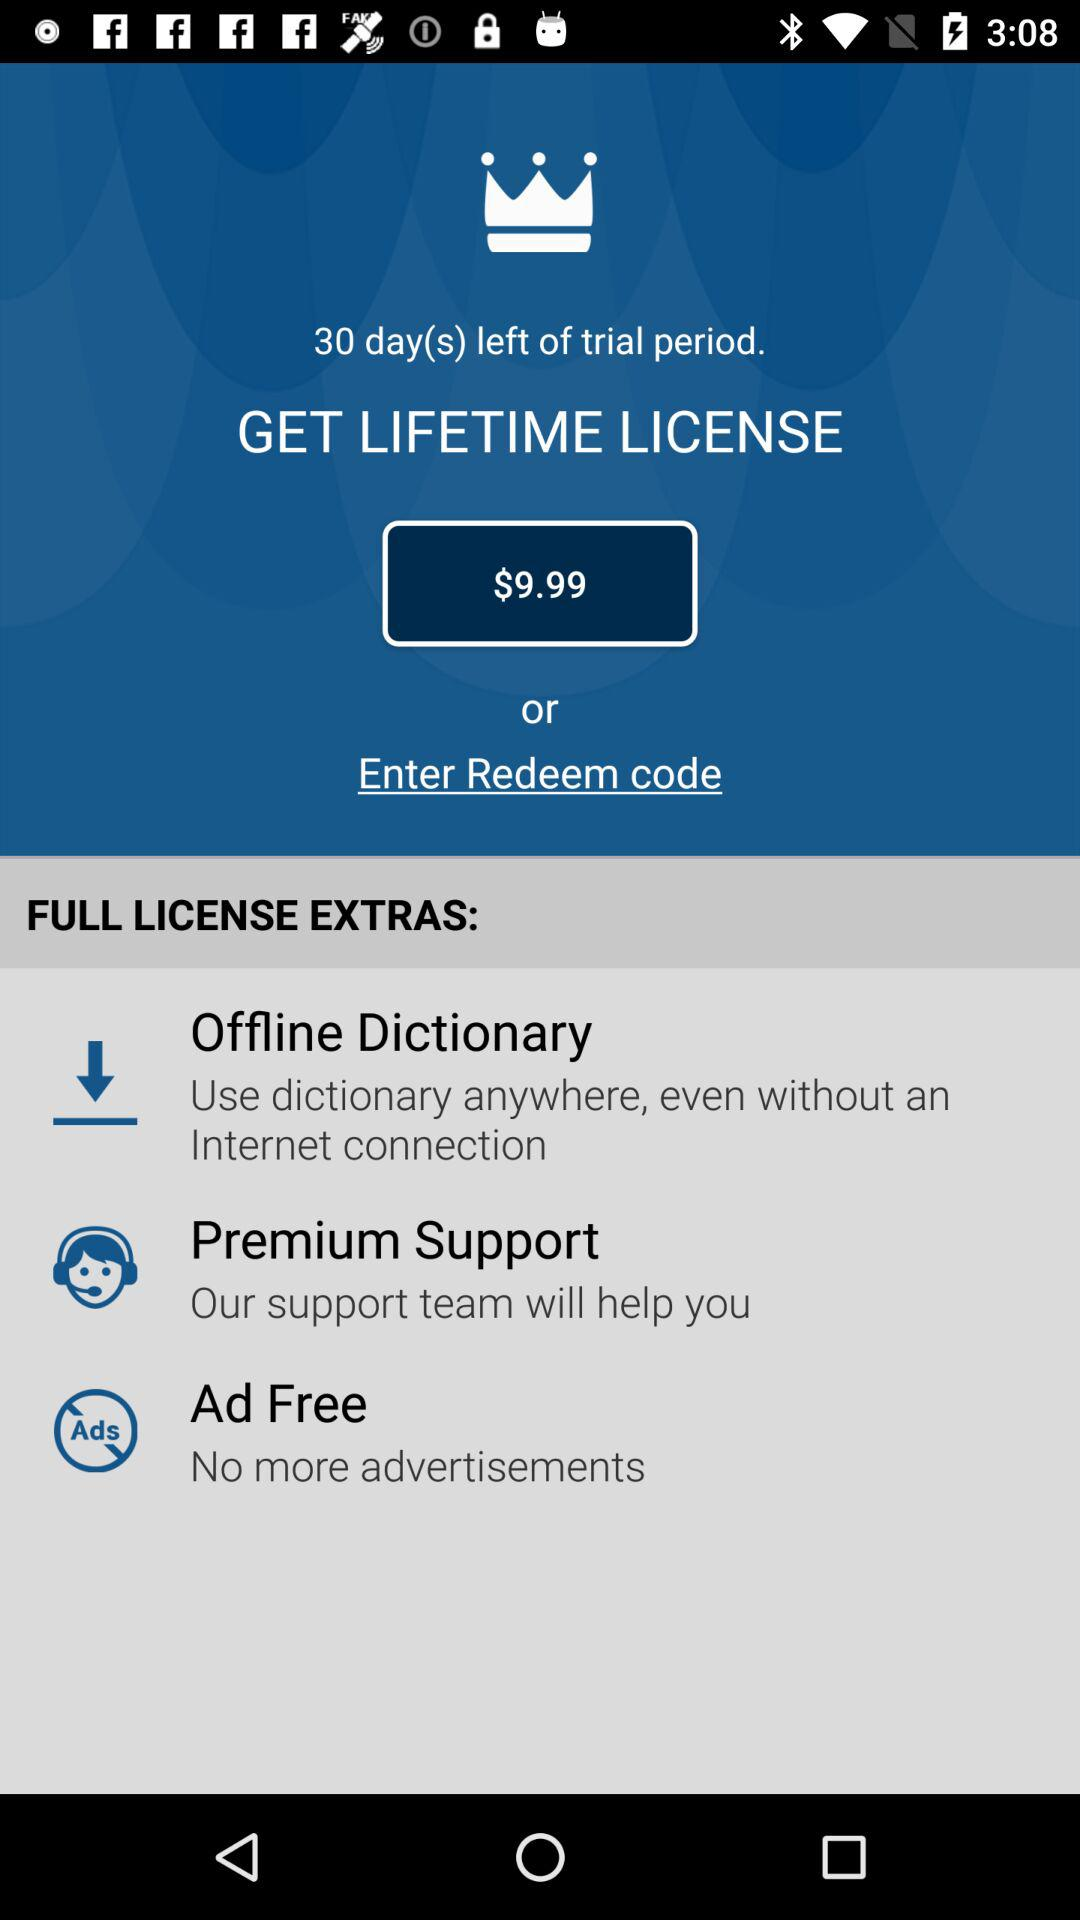What is the price? The price is $9.99. 